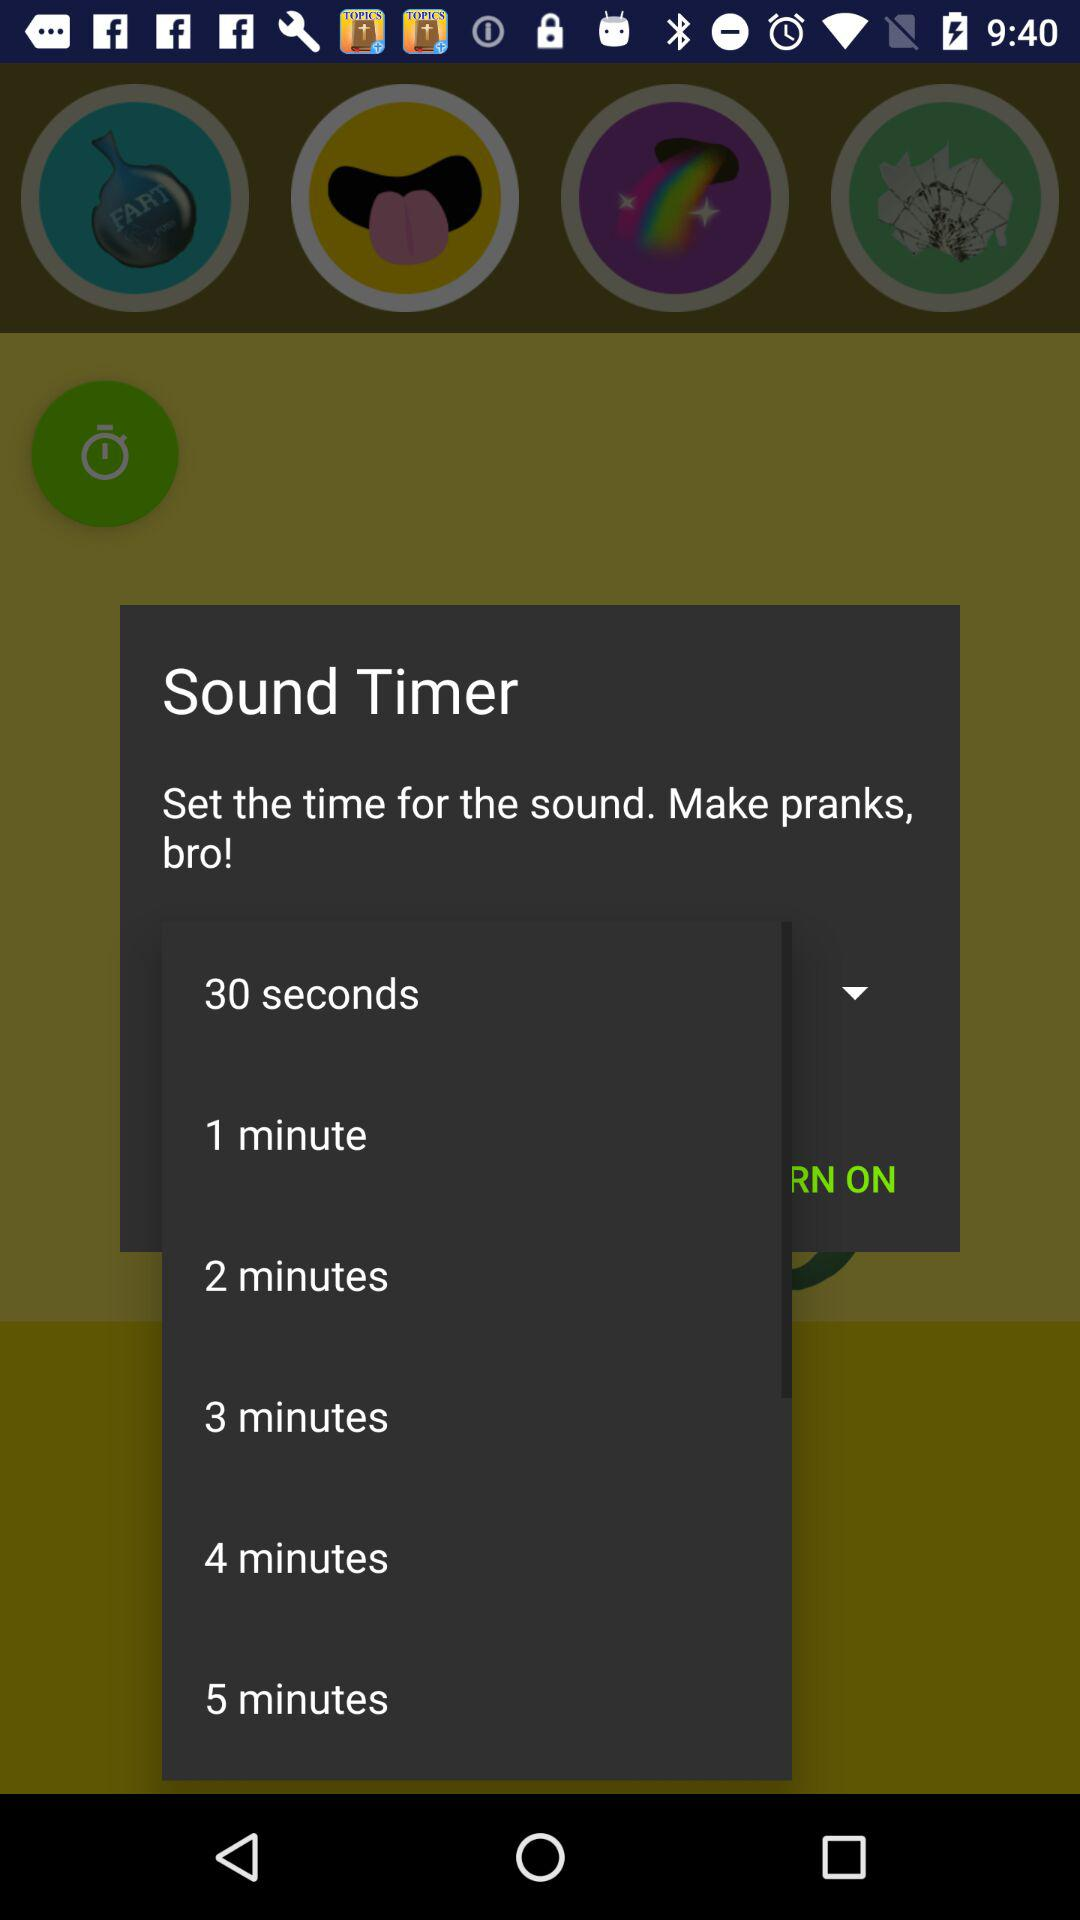How many seconds does the shortest time option last?
Answer the question using a single word or phrase. 30 